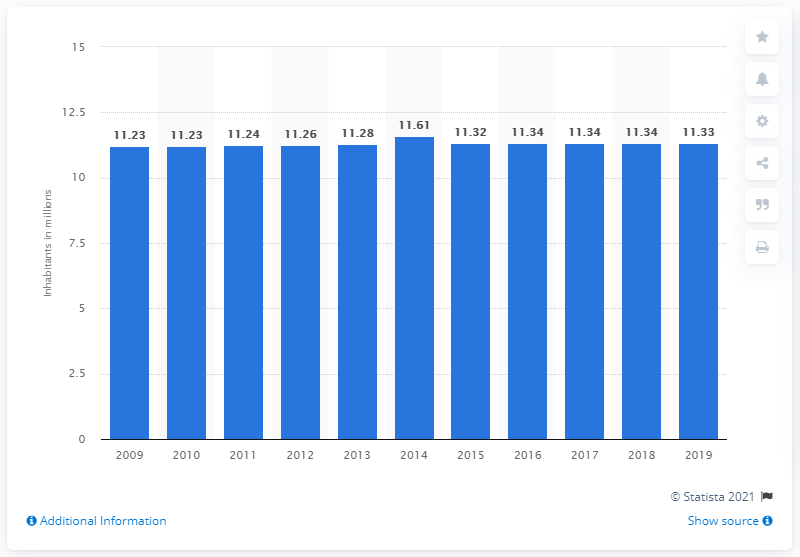Give some essential details in this illustration. The population of Cuba in 2019 was approximately 11.33 million. 